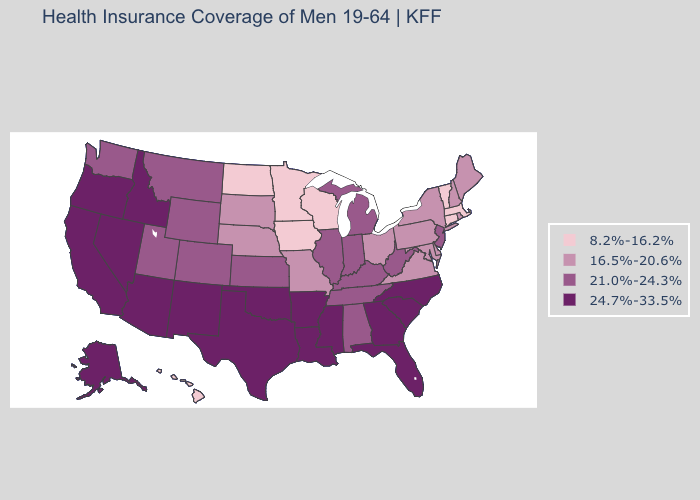Which states hav the highest value in the Northeast?
Give a very brief answer. New Jersey. Which states have the lowest value in the USA?
Keep it brief. Connecticut, Hawaii, Iowa, Massachusetts, Minnesota, North Dakota, Vermont, Wisconsin. Does Missouri have the highest value in the USA?
Short answer required. No. Name the states that have a value in the range 16.5%-20.6%?
Short answer required. Delaware, Maine, Maryland, Missouri, Nebraska, New Hampshire, New York, Ohio, Pennsylvania, Rhode Island, South Dakota, Virginia. What is the lowest value in the USA?
Be succinct. 8.2%-16.2%. Does South Dakota have the lowest value in the MidWest?
Answer briefly. No. What is the highest value in the Northeast ?
Concise answer only. 21.0%-24.3%. Name the states that have a value in the range 8.2%-16.2%?
Quick response, please. Connecticut, Hawaii, Iowa, Massachusetts, Minnesota, North Dakota, Vermont, Wisconsin. Name the states that have a value in the range 8.2%-16.2%?
Give a very brief answer. Connecticut, Hawaii, Iowa, Massachusetts, Minnesota, North Dakota, Vermont, Wisconsin. Name the states that have a value in the range 8.2%-16.2%?
Keep it brief. Connecticut, Hawaii, Iowa, Massachusetts, Minnesota, North Dakota, Vermont, Wisconsin. Does the map have missing data?
Be succinct. No. Which states have the highest value in the USA?
Answer briefly. Alaska, Arizona, Arkansas, California, Florida, Georgia, Idaho, Louisiana, Mississippi, Nevada, New Mexico, North Carolina, Oklahoma, Oregon, South Carolina, Texas. What is the value of Massachusetts?
Answer briefly. 8.2%-16.2%. Name the states that have a value in the range 21.0%-24.3%?
Short answer required. Alabama, Colorado, Illinois, Indiana, Kansas, Kentucky, Michigan, Montana, New Jersey, Tennessee, Utah, Washington, West Virginia, Wyoming. Does New Jersey have the highest value in the Northeast?
Give a very brief answer. Yes. 